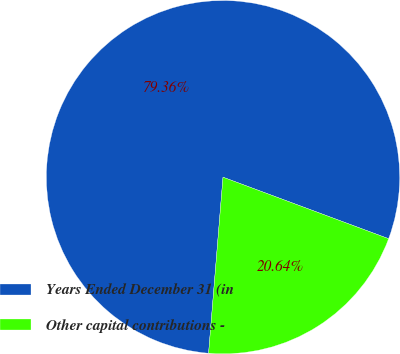Convert chart to OTSL. <chart><loc_0><loc_0><loc_500><loc_500><pie_chart><fcel>Years Ended December 31 (in<fcel>Other capital contributions -<nl><fcel>79.36%<fcel>20.64%<nl></chart> 